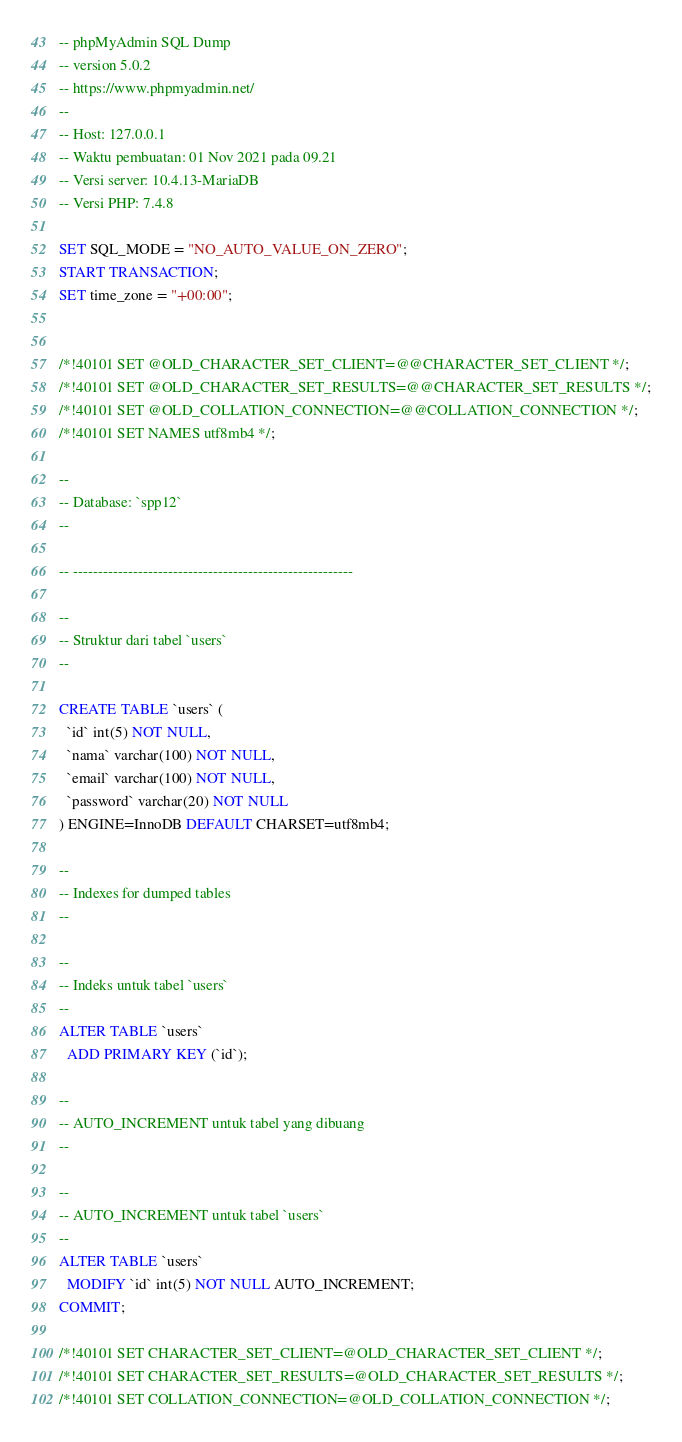<code> <loc_0><loc_0><loc_500><loc_500><_SQL_>-- phpMyAdmin SQL Dump
-- version 5.0.2
-- https://www.phpmyadmin.net/
--
-- Host: 127.0.0.1
-- Waktu pembuatan: 01 Nov 2021 pada 09.21
-- Versi server: 10.4.13-MariaDB
-- Versi PHP: 7.4.8

SET SQL_MODE = "NO_AUTO_VALUE_ON_ZERO";
START TRANSACTION;
SET time_zone = "+00:00";


/*!40101 SET @OLD_CHARACTER_SET_CLIENT=@@CHARACTER_SET_CLIENT */;
/*!40101 SET @OLD_CHARACTER_SET_RESULTS=@@CHARACTER_SET_RESULTS */;
/*!40101 SET @OLD_COLLATION_CONNECTION=@@COLLATION_CONNECTION */;
/*!40101 SET NAMES utf8mb4 */;

--
-- Database: `spp12`
--

-- --------------------------------------------------------

--
-- Struktur dari tabel `users`
--

CREATE TABLE `users` (
  `id` int(5) NOT NULL,
  `nama` varchar(100) NOT NULL,
  `email` varchar(100) NOT NULL,
  `password` varchar(20) NOT NULL
) ENGINE=InnoDB DEFAULT CHARSET=utf8mb4;

--
-- Indexes for dumped tables
--

--
-- Indeks untuk tabel `users`
--
ALTER TABLE `users`
  ADD PRIMARY KEY (`id`);

--
-- AUTO_INCREMENT untuk tabel yang dibuang
--

--
-- AUTO_INCREMENT untuk tabel `users`
--
ALTER TABLE `users`
  MODIFY `id` int(5) NOT NULL AUTO_INCREMENT;
COMMIT;

/*!40101 SET CHARACTER_SET_CLIENT=@OLD_CHARACTER_SET_CLIENT */;
/*!40101 SET CHARACTER_SET_RESULTS=@OLD_CHARACTER_SET_RESULTS */;
/*!40101 SET COLLATION_CONNECTION=@OLD_COLLATION_CONNECTION */;
</code> 